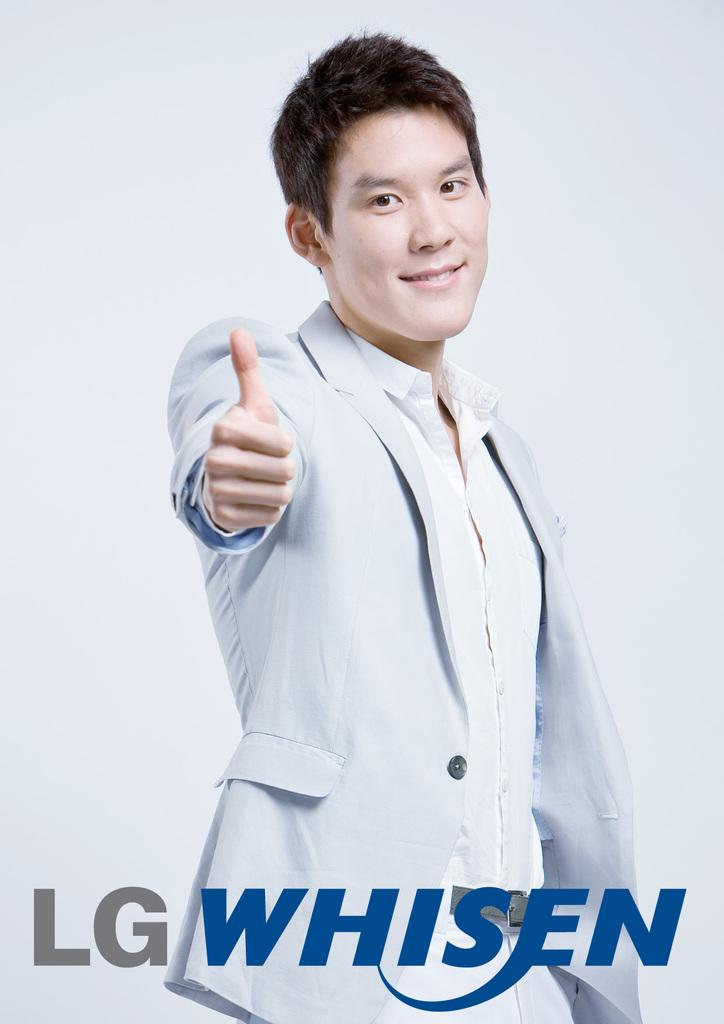What is the color of the wall in the image? The wall in the image is white. Who is present in the image? There is a man in the image. What is the man wearing? The man is wearing a jacket. How many dolls can be seen interacting with the man in the image? There are no dolls present in the image; it only features a man standing near a white wall. 